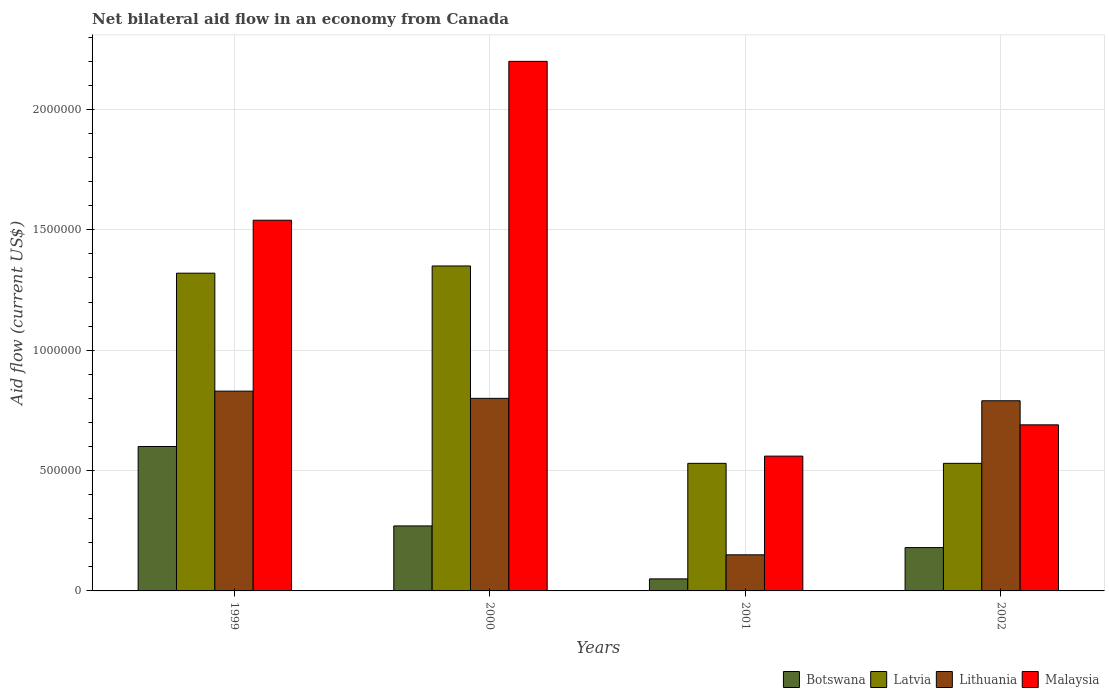How many groups of bars are there?
Provide a short and direct response. 4. How many bars are there on the 4th tick from the left?
Provide a short and direct response. 4. How many bars are there on the 3rd tick from the right?
Provide a short and direct response. 4. What is the label of the 1st group of bars from the left?
Keep it short and to the point. 1999. Across all years, what is the maximum net bilateral aid flow in Malaysia?
Offer a terse response. 2.20e+06. Across all years, what is the minimum net bilateral aid flow in Latvia?
Offer a terse response. 5.30e+05. In which year was the net bilateral aid flow in Botswana maximum?
Give a very brief answer. 1999. In which year was the net bilateral aid flow in Malaysia minimum?
Ensure brevity in your answer.  2001. What is the total net bilateral aid flow in Latvia in the graph?
Your answer should be very brief. 3.73e+06. What is the average net bilateral aid flow in Latvia per year?
Your response must be concise. 9.32e+05. What is the ratio of the net bilateral aid flow in Botswana in 2001 to that in 2002?
Your answer should be very brief. 0.28. Is the difference between the net bilateral aid flow in Latvia in 2000 and 2001 greater than the difference between the net bilateral aid flow in Lithuania in 2000 and 2001?
Provide a short and direct response. Yes. What is the difference between the highest and the lowest net bilateral aid flow in Latvia?
Your answer should be compact. 8.20e+05. Is it the case that in every year, the sum of the net bilateral aid flow in Latvia and net bilateral aid flow in Botswana is greater than the sum of net bilateral aid flow in Malaysia and net bilateral aid flow in Lithuania?
Offer a terse response. No. What does the 1st bar from the left in 2001 represents?
Make the answer very short. Botswana. What does the 4th bar from the right in 2000 represents?
Offer a terse response. Botswana. Are all the bars in the graph horizontal?
Keep it short and to the point. No. What is the difference between two consecutive major ticks on the Y-axis?
Provide a short and direct response. 5.00e+05. Are the values on the major ticks of Y-axis written in scientific E-notation?
Ensure brevity in your answer.  No. Does the graph contain grids?
Provide a succinct answer. Yes. Where does the legend appear in the graph?
Your response must be concise. Bottom right. How are the legend labels stacked?
Offer a very short reply. Horizontal. What is the title of the graph?
Make the answer very short. Net bilateral aid flow in an economy from Canada. What is the label or title of the X-axis?
Make the answer very short. Years. What is the label or title of the Y-axis?
Provide a succinct answer. Aid flow (current US$). What is the Aid flow (current US$) of Botswana in 1999?
Offer a very short reply. 6.00e+05. What is the Aid flow (current US$) in Latvia in 1999?
Ensure brevity in your answer.  1.32e+06. What is the Aid flow (current US$) in Lithuania in 1999?
Provide a short and direct response. 8.30e+05. What is the Aid flow (current US$) of Malaysia in 1999?
Your answer should be compact. 1.54e+06. What is the Aid flow (current US$) of Botswana in 2000?
Offer a very short reply. 2.70e+05. What is the Aid flow (current US$) in Latvia in 2000?
Offer a terse response. 1.35e+06. What is the Aid flow (current US$) of Lithuania in 2000?
Your response must be concise. 8.00e+05. What is the Aid flow (current US$) in Malaysia in 2000?
Give a very brief answer. 2.20e+06. What is the Aid flow (current US$) of Botswana in 2001?
Provide a short and direct response. 5.00e+04. What is the Aid flow (current US$) of Latvia in 2001?
Offer a very short reply. 5.30e+05. What is the Aid flow (current US$) in Lithuania in 2001?
Give a very brief answer. 1.50e+05. What is the Aid flow (current US$) of Malaysia in 2001?
Your response must be concise. 5.60e+05. What is the Aid flow (current US$) of Latvia in 2002?
Your response must be concise. 5.30e+05. What is the Aid flow (current US$) of Lithuania in 2002?
Give a very brief answer. 7.90e+05. What is the Aid flow (current US$) of Malaysia in 2002?
Provide a short and direct response. 6.90e+05. Across all years, what is the maximum Aid flow (current US$) of Botswana?
Your response must be concise. 6.00e+05. Across all years, what is the maximum Aid flow (current US$) of Latvia?
Ensure brevity in your answer.  1.35e+06. Across all years, what is the maximum Aid flow (current US$) in Lithuania?
Ensure brevity in your answer.  8.30e+05. Across all years, what is the maximum Aid flow (current US$) of Malaysia?
Your response must be concise. 2.20e+06. Across all years, what is the minimum Aid flow (current US$) of Latvia?
Give a very brief answer. 5.30e+05. Across all years, what is the minimum Aid flow (current US$) of Lithuania?
Ensure brevity in your answer.  1.50e+05. Across all years, what is the minimum Aid flow (current US$) of Malaysia?
Give a very brief answer. 5.60e+05. What is the total Aid flow (current US$) of Botswana in the graph?
Your answer should be very brief. 1.10e+06. What is the total Aid flow (current US$) in Latvia in the graph?
Make the answer very short. 3.73e+06. What is the total Aid flow (current US$) in Lithuania in the graph?
Your response must be concise. 2.57e+06. What is the total Aid flow (current US$) of Malaysia in the graph?
Make the answer very short. 4.99e+06. What is the difference between the Aid flow (current US$) of Lithuania in 1999 and that in 2000?
Your answer should be very brief. 3.00e+04. What is the difference between the Aid flow (current US$) of Malaysia in 1999 and that in 2000?
Offer a terse response. -6.60e+05. What is the difference between the Aid flow (current US$) of Botswana in 1999 and that in 2001?
Provide a succinct answer. 5.50e+05. What is the difference between the Aid flow (current US$) in Latvia in 1999 and that in 2001?
Your answer should be very brief. 7.90e+05. What is the difference between the Aid flow (current US$) of Lithuania in 1999 and that in 2001?
Make the answer very short. 6.80e+05. What is the difference between the Aid flow (current US$) of Malaysia in 1999 and that in 2001?
Keep it short and to the point. 9.80e+05. What is the difference between the Aid flow (current US$) in Latvia in 1999 and that in 2002?
Keep it short and to the point. 7.90e+05. What is the difference between the Aid flow (current US$) in Malaysia in 1999 and that in 2002?
Give a very brief answer. 8.50e+05. What is the difference between the Aid flow (current US$) of Latvia in 2000 and that in 2001?
Your response must be concise. 8.20e+05. What is the difference between the Aid flow (current US$) in Lithuania in 2000 and that in 2001?
Provide a succinct answer. 6.50e+05. What is the difference between the Aid flow (current US$) of Malaysia in 2000 and that in 2001?
Ensure brevity in your answer.  1.64e+06. What is the difference between the Aid flow (current US$) in Botswana in 2000 and that in 2002?
Keep it short and to the point. 9.00e+04. What is the difference between the Aid flow (current US$) in Latvia in 2000 and that in 2002?
Your answer should be compact. 8.20e+05. What is the difference between the Aid flow (current US$) of Malaysia in 2000 and that in 2002?
Keep it short and to the point. 1.51e+06. What is the difference between the Aid flow (current US$) in Botswana in 2001 and that in 2002?
Keep it short and to the point. -1.30e+05. What is the difference between the Aid flow (current US$) in Latvia in 2001 and that in 2002?
Offer a terse response. 0. What is the difference between the Aid flow (current US$) of Lithuania in 2001 and that in 2002?
Ensure brevity in your answer.  -6.40e+05. What is the difference between the Aid flow (current US$) of Botswana in 1999 and the Aid flow (current US$) of Latvia in 2000?
Your answer should be very brief. -7.50e+05. What is the difference between the Aid flow (current US$) in Botswana in 1999 and the Aid flow (current US$) in Lithuania in 2000?
Keep it short and to the point. -2.00e+05. What is the difference between the Aid flow (current US$) of Botswana in 1999 and the Aid flow (current US$) of Malaysia in 2000?
Offer a terse response. -1.60e+06. What is the difference between the Aid flow (current US$) of Latvia in 1999 and the Aid flow (current US$) of Lithuania in 2000?
Ensure brevity in your answer.  5.20e+05. What is the difference between the Aid flow (current US$) of Latvia in 1999 and the Aid flow (current US$) of Malaysia in 2000?
Ensure brevity in your answer.  -8.80e+05. What is the difference between the Aid flow (current US$) of Lithuania in 1999 and the Aid flow (current US$) of Malaysia in 2000?
Provide a succinct answer. -1.37e+06. What is the difference between the Aid flow (current US$) of Botswana in 1999 and the Aid flow (current US$) of Latvia in 2001?
Provide a short and direct response. 7.00e+04. What is the difference between the Aid flow (current US$) of Botswana in 1999 and the Aid flow (current US$) of Lithuania in 2001?
Provide a succinct answer. 4.50e+05. What is the difference between the Aid flow (current US$) in Latvia in 1999 and the Aid flow (current US$) in Lithuania in 2001?
Your answer should be compact. 1.17e+06. What is the difference between the Aid flow (current US$) of Latvia in 1999 and the Aid flow (current US$) of Malaysia in 2001?
Your answer should be compact. 7.60e+05. What is the difference between the Aid flow (current US$) of Lithuania in 1999 and the Aid flow (current US$) of Malaysia in 2001?
Ensure brevity in your answer.  2.70e+05. What is the difference between the Aid flow (current US$) of Botswana in 1999 and the Aid flow (current US$) of Lithuania in 2002?
Provide a short and direct response. -1.90e+05. What is the difference between the Aid flow (current US$) of Latvia in 1999 and the Aid flow (current US$) of Lithuania in 2002?
Provide a succinct answer. 5.30e+05. What is the difference between the Aid flow (current US$) in Latvia in 1999 and the Aid flow (current US$) in Malaysia in 2002?
Provide a short and direct response. 6.30e+05. What is the difference between the Aid flow (current US$) in Lithuania in 1999 and the Aid flow (current US$) in Malaysia in 2002?
Offer a very short reply. 1.40e+05. What is the difference between the Aid flow (current US$) in Botswana in 2000 and the Aid flow (current US$) in Latvia in 2001?
Give a very brief answer. -2.60e+05. What is the difference between the Aid flow (current US$) of Botswana in 2000 and the Aid flow (current US$) of Malaysia in 2001?
Provide a short and direct response. -2.90e+05. What is the difference between the Aid flow (current US$) in Latvia in 2000 and the Aid flow (current US$) in Lithuania in 2001?
Ensure brevity in your answer.  1.20e+06. What is the difference between the Aid flow (current US$) in Latvia in 2000 and the Aid flow (current US$) in Malaysia in 2001?
Your answer should be compact. 7.90e+05. What is the difference between the Aid flow (current US$) in Lithuania in 2000 and the Aid flow (current US$) in Malaysia in 2001?
Your response must be concise. 2.40e+05. What is the difference between the Aid flow (current US$) in Botswana in 2000 and the Aid flow (current US$) in Latvia in 2002?
Provide a succinct answer. -2.60e+05. What is the difference between the Aid flow (current US$) in Botswana in 2000 and the Aid flow (current US$) in Lithuania in 2002?
Your answer should be very brief. -5.20e+05. What is the difference between the Aid flow (current US$) in Botswana in 2000 and the Aid flow (current US$) in Malaysia in 2002?
Offer a very short reply. -4.20e+05. What is the difference between the Aid flow (current US$) of Latvia in 2000 and the Aid flow (current US$) of Lithuania in 2002?
Your answer should be compact. 5.60e+05. What is the difference between the Aid flow (current US$) of Latvia in 2000 and the Aid flow (current US$) of Malaysia in 2002?
Provide a short and direct response. 6.60e+05. What is the difference between the Aid flow (current US$) in Botswana in 2001 and the Aid flow (current US$) in Latvia in 2002?
Offer a very short reply. -4.80e+05. What is the difference between the Aid flow (current US$) of Botswana in 2001 and the Aid flow (current US$) of Lithuania in 2002?
Provide a short and direct response. -7.40e+05. What is the difference between the Aid flow (current US$) in Botswana in 2001 and the Aid flow (current US$) in Malaysia in 2002?
Give a very brief answer. -6.40e+05. What is the difference between the Aid flow (current US$) of Latvia in 2001 and the Aid flow (current US$) of Malaysia in 2002?
Keep it short and to the point. -1.60e+05. What is the difference between the Aid flow (current US$) of Lithuania in 2001 and the Aid flow (current US$) of Malaysia in 2002?
Keep it short and to the point. -5.40e+05. What is the average Aid flow (current US$) in Botswana per year?
Offer a terse response. 2.75e+05. What is the average Aid flow (current US$) of Latvia per year?
Offer a very short reply. 9.32e+05. What is the average Aid flow (current US$) in Lithuania per year?
Offer a terse response. 6.42e+05. What is the average Aid flow (current US$) of Malaysia per year?
Give a very brief answer. 1.25e+06. In the year 1999, what is the difference between the Aid flow (current US$) in Botswana and Aid flow (current US$) in Latvia?
Your response must be concise. -7.20e+05. In the year 1999, what is the difference between the Aid flow (current US$) in Botswana and Aid flow (current US$) in Lithuania?
Your answer should be compact. -2.30e+05. In the year 1999, what is the difference between the Aid flow (current US$) of Botswana and Aid flow (current US$) of Malaysia?
Your answer should be compact. -9.40e+05. In the year 1999, what is the difference between the Aid flow (current US$) of Latvia and Aid flow (current US$) of Malaysia?
Provide a short and direct response. -2.20e+05. In the year 1999, what is the difference between the Aid flow (current US$) in Lithuania and Aid flow (current US$) in Malaysia?
Offer a very short reply. -7.10e+05. In the year 2000, what is the difference between the Aid flow (current US$) of Botswana and Aid flow (current US$) of Latvia?
Give a very brief answer. -1.08e+06. In the year 2000, what is the difference between the Aid flow (current US$) of Botswana and Aid flow (current US$) of Lithuania?
Your answer should be very brief. -5.30e+05. In the year 2000, what is the difference between the Aid flow (current US$) of Botswana and Aid flow (current US$) of Malaysia?
Provide a short and direct response. -1.93e+06. In the year 2000, what is the difference between the Aid flow (current US$) in Latvia and Aid flow (current US$) in Malaysia?
Your response must be concise. -8.50e+05. In the year 2000, what is the difference between the Aid flow (current US$) of Lithuania and Aid flow (current US$) of Malaysia?
Offer a very short reply. -1.40e+06. In the year 2001, what is the difference between the Aid flow (current US$) in Botswana and Aid flow (current US$) in Latvia?
Ensure brevity in your answer.  -4.80e+05. In the year 2001, what is the difference between the Aid flow (current US$) of Botswana and Aid flow (current US$) of Malaysia?
Ensure brevity in your answer.  -5.10e+05. In the year 2001, what is the difference between the Aid flow (current US$) of Latvia and Aid flow (current US$) of Malaysia?
Your response must be concise. -3.00e+04. In the year 2001, what is the difference between the Aid flow (current US$) of Lithuania and Aid flow (current US$) of Malaysia?
Offer a terse response. -4.10e+05. In the year 2002, what is the difference between the Aid flow (current US$) in Botswana and Aid flow (current US$) in Latvia?
Make the answer very short. -3.50e+05. In the year 2002, what is the difference between the Aid flow (current US$) in Botswana and Aid flow (current US$) in Lithuania?
Provide a short and direct response. -6.10e+05. In the year 2002, what is the difference between the Aid flow (current US$) of Botswana and Aid flow (current US$) of Malaysia?
Offer a terse response. -5.10e+05. In the year 2002, what is the difference between the Aid flow (current US$) of Latvia and Aid flow (current US$) of Malaysia?
Offer a very short reply. -1.60e+05. In the year 2002, what is the difference between the Aid flow (current US$) in Lithuania and Aid flow (current US$) in Malaysia?
Give a very brief answer. 1.00e+05. What is the ratio of the Aid flow (current US$) in Botswana in 1999 to that in 2000?
Offer a very short reply. 2.22. What is the ratio of the Aid flow (current US$) of Latvia in 1999 to that in 2000?
Ensure brevity in your answer.  0.98. What is the ratio of the Aid flow (current US$) in Lithuania in 1999 to that in 2000?
Ensure brevity in your answer.  1.04. What is the ratio of the Aid flow (current US$) in Malaysia in 1999 to that in 2000?
Provide a succinct answer. 0.7. What is the ratio of the Aid flow (current US$) of Botswana in 1999 to that in 2001?
Give a very brief answer. 12. What is the ratio of the Aid flow (current US$) in Latvia in 1999 to that in 2001?
Make the answer very short. 2.49. What is the ratio of the Aid flow (current US$) of Lithuania in 1999 to that in 2001?
Your answer should be compact. 5.53. What is the ratio of the Aid flow (current US$) of Malaysia in 1999 to that in 2001?
Offer a very short reply. 2.75. What is the ratio of the Aid flow (current US$) in Botswana in 1999 to that in 2002?
Offer a very short reply. 3.33. What is the ratio of the Aid flow (current US$) in Latvia in 1999 to that in 2002?
Offer a very short reply. 2.49. What is the ratio of the Aid flow (current US$) in Lithuania in 1999 to that in 2002?
Your answer should be compact. 1.05. What is the ratio of the Aid flow (current US$) of Malaysia in 1999 to that in 2002?
Give a very brief answer. 2.23. What is the ratio of the Aid flow (current US$) of Botswana in 2000 to that in 2001?
Your answer should be compact. 5.4. What is the ratio of the Aid flow (current US$) of Latvia in 2000 to that in 2001?
Give a very brief answer. 2.55. What is the ratio of the Aid flow (current US$) of Lithuania in 2000 to that in 2001?
Provide a short and direct response. 5.33. What is the ratio of the Aid flow (current US$) in Malaysia in 2000 to that in 2001?
Your answer should be very brief. 3.93. What is the ratio of the Aid flow (current US$) in Botswana in 2000 to that in 2002?
Your answer should be compact. 1.5. What is the ratio of the Aid flow (current US$) of Latvia in 2000 to that in 2002?
Give a very brief answer. 2.55. What is the ratio of the Aid flow (current US$) in Lithuania in 2000 to that in 2002?
Provide a short and direct response. 1.01. What is the ratio of the Aid flow (current US$) in Malaysia in 2000 to that in 2002?
Your answer should be compact. 3.19. What is the ratio of the Aid flow (current US$) in Botswana in 2001 to that in 2002?
Your answer should be compact. 0.28. What is the ratio of the Aid flow (current US$) of Lithuania in 2001 to that in 2002?
Offer a very short reply. 0.19. What is the ratio of the Aid flow (current US$) of Malaysia in 2001 to that in 2002?
Give a very brief answer. 0.81. What is the difference between the highest and the second highest Aid flow (current US$) of Botswana?
Your answer should be compact. 3.30e+05. What is the difference between the highest and the second highest Aid flow (current US$) of Latvia?
Give a very brief answer. 3.00e+04. What is the difference between the highest and the second highest Aid flow (current US$) in Malaysia?
Provide a short and direct response. 6.60e+05. What is the difference between the highest and the lowest Aid flow (current US$) in Latvia?
Your answer should be compact. 8.20e+05. What is the difference between the highest and the lowest Aid flow (current US$) of Lithuania?
Provide a succinct answer. 6.80e+05. What is the difference between the highest and the lowest Aid flow (current US$) in Malaysia?
Ensure brevity in your answer.  1.64e+06. 